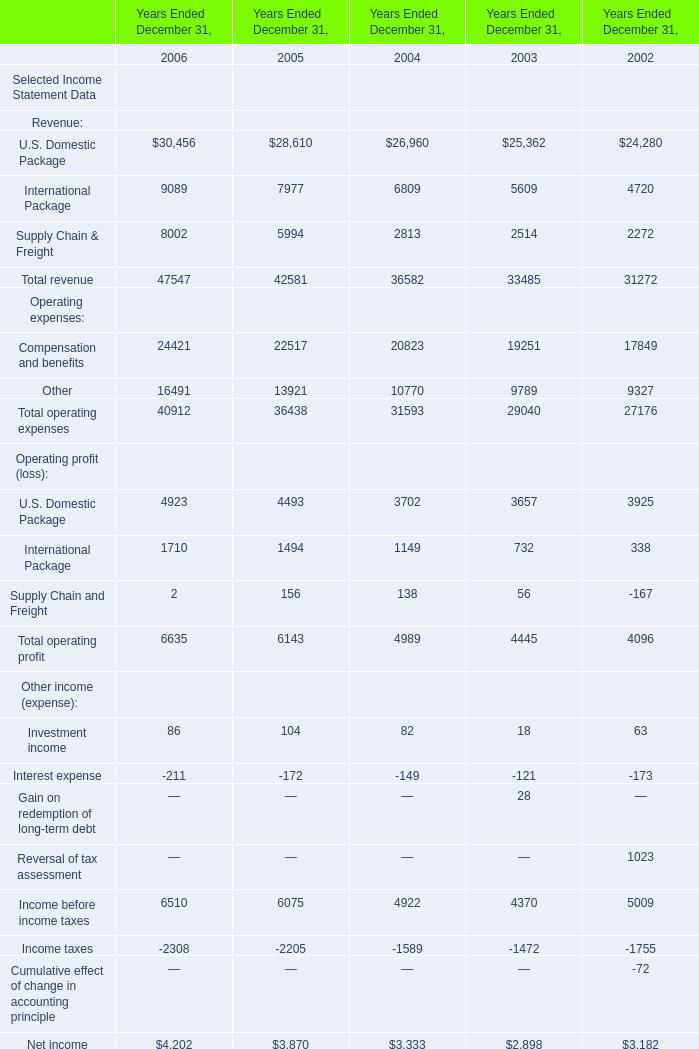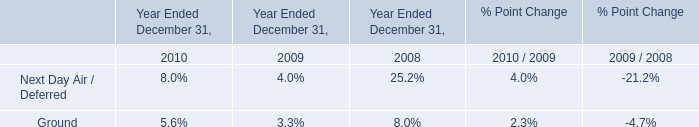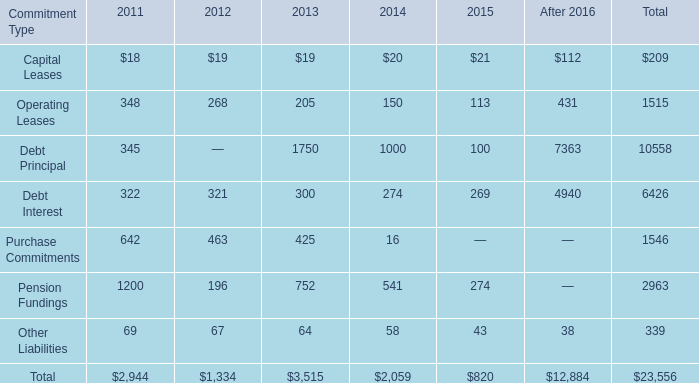What's the average of International Package of Years Ended December 31, 2005, and Debt Principal of After 2016 ? 
Computations: ((7977.0 + 7363.0) / 2)
Answer: 7670.0. 